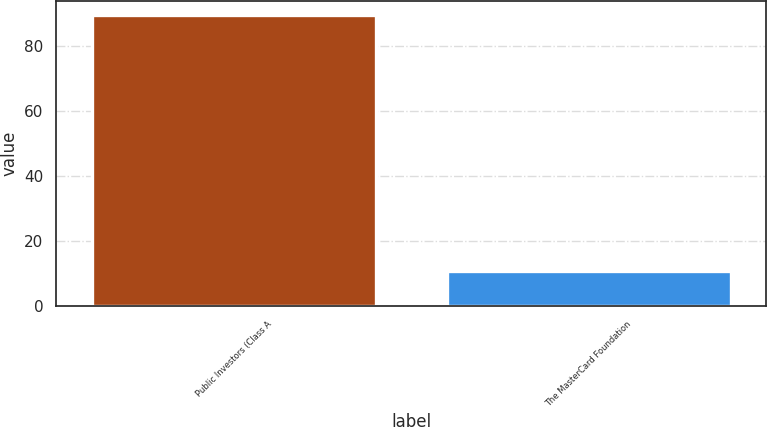Convert chart. <chart><loc_0><loc_0><loc_500><loc_500><bar_chart><fcel>Public Investors (Class A<fcel>The MasterCard Foundation<nl><fcel>89.3<fcel>10.7<nl></chart> 